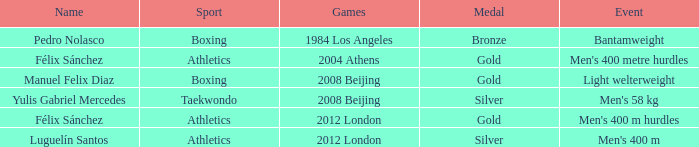What Medal had a Name of manuel felix diaz? Gold. 